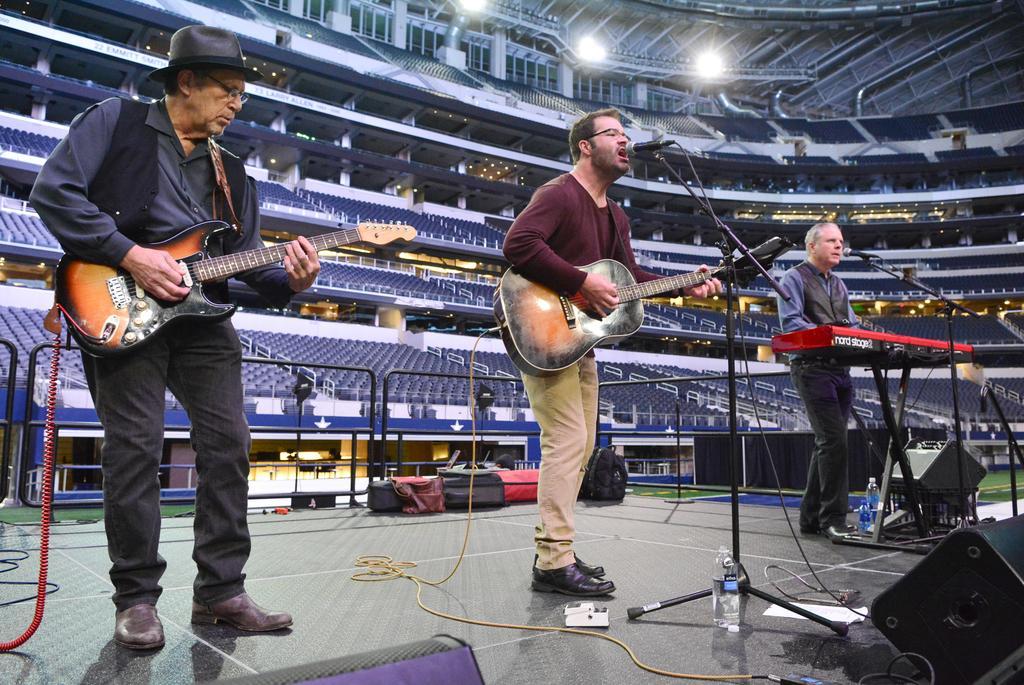How would you summarize this image in a sentence or two? This picture describes about three musicians, the left person is playing guitar, the middle person is singing and playing guitar with the help of microphone, and the right side person is playing keyboard in front of microphone, in front of them we can find couple of bottles and speakers, in the background we can see baggage, metal rods, couple of seats and couple of lights. 